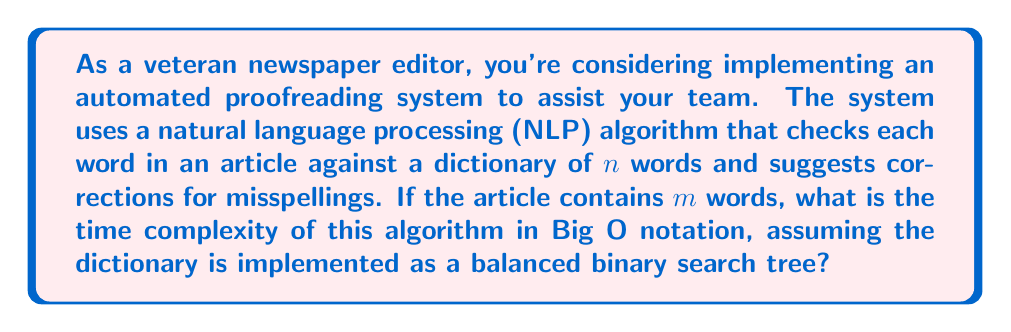Provide a solution to this math problem. To analyze the time complexity of this algorithm, we need to consider the following steps:

1. For each word in the article (total $m$ words):
   a. Search the dictionary (containing $n$ words) for the current word.
   b. If the word is not found, generate suggestions.

2. Searching in a balanced binary search tree:
   The time complexity of searching in a balanced binary search tree is $O(\log n)$, where $n$ is the number of nodes (words in our dictionary).

3. Generating suggestions:
   Let's assume the suggestion generation takes constant time $O(1)$ for simplicity.

4. Total time complexity:
   - We perform the search operation $m$ times (once for each word in the article).
   - Each search operation takes $O(\log n)$ time.
   - The suggestion generation is $O(1)$ and doesn't affect the overall complexity.

   Therefore, the total time complexity is:
   
   $$O(m \cdot \log n)$$

This complexity represents the worst-case scenario where every word needs to be checked against the dictionary.

For a newspaper editor, this means that the processing time increases linearly with the number of words in the article, and logarithmically with the size of the dictionary. This scalability allows for efficient proofreading of articles of various lengths, even with a large dictionary.
Answer: $O(m \cdot \log n)$, where $m$ is the number of words in the article and $n$ is the number of words in the dictionary. 